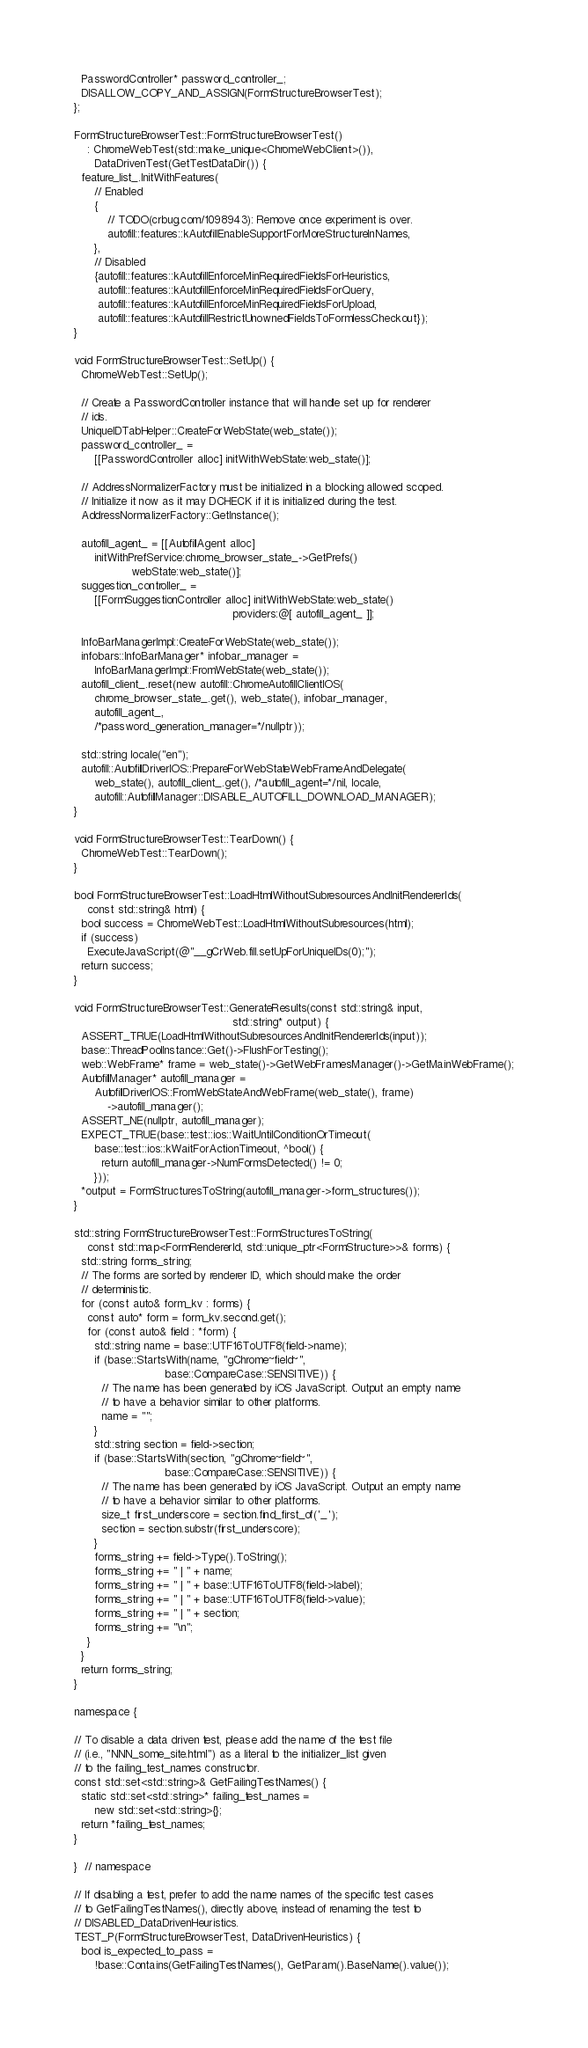Convert code to text. <code><loc_0><loc_0><loc_500><loc_500><_ObjectiveC_>  PasswordController* password_controller_;
  DISALLOW_COPY_AND_ASSIGN(FormStructureBrowserTest);
};

FormStructureBrowserTest::FormStructureBrowserTest()
    : ChromeWebTest(std::make_unique<ChromeWebClient>()),
      DataDrivenTest(GetTestDataDir()) {
  feature_list_.InitWithFeatures(
      // Enabled
      {
          // TODO(crbug.com/1098943): Remove once experiment is over.
          autofill::features::kAutofillEnableSupportForMoreStructureInNames,
      },
      // Disabled
      {autofill::features::kAutofillEnforceMinRequiredFieldsForHeuristics,
       autofill::features::kAutofillEnforceMinRequiredFieldsForQuery,
       autofill::features::kAutofillEnforceMinRequiredFieldsForUpload,
       autofill::features::kAutofillRestrictUnownedFieldsToFormlessCheckout});
}

void FormStructureBrowserTest::SetUp() {
  ChromeWebTest::SetUp();

  // Create a PasswordController instance that will handle set up for renderer
  // ids.
  UniqueIDTabHelper::CreateForWebState(web_state());
  password_controller_ =
      [[PasswordController alloc] initWithWebState:web_state()];

  // AddressNormalizerFactory must be initialized in a blocking allowed scoped.
  // Initialize it now as it may DCHECK if it is initialized during the test.
  AddressNormalizerFactory::GetInstance();

  autofill_agent_ = [[AutofillAgent alloc]
      initWithPrefService:chrome_browser_state_->GetPrefs()
                 webState:web_state()];
  suggestion_controller_ =
      [[FormSuggestionController alloc] initWithWebState:web_state()
                                               providers:@[ autofill_agent_ ]];

  InfoBarManagerImpl::CreateForWebState(web_state());
  infobars::InfoBarManager* infobar_manager =
      InfoBarManagerImpl::FromWebState(web_state());
  autofill_client_.reset(new autofill::ChromeAutofillClientIOS(
      chrome_browser_state_.get(), web_state(), infobar_manager,
      autofill_agent_,
      /*password_generation_manager=*/nullptr));

  std::string locale("en");
  autofill::AutofillDriverIOS::PrepareForWebStateWebFrameAndDelegate(
      web_state(), autofill_client_.get(), /*autofill_agent=*/nil, locale,
      autofill::AutofillManager::DISABLE_AUTOFILL_DOWNLOAD_MANAGER);
}

void FormStructureBrowserTest::TearDown() {
  ChromeWebTest::TearDown();
}

bool FormStructureBrowserTest::LoadHtmlWithoutSubresourcesAndInitRendererIds(
    const std::string& html) {
  bool success = ChromeWebTest::LoadHtmlWithoutSubresources(html);
  if (success)
    ExecuteJavaScript(@"__gCrWeb.fill.setUpForUniqueIDs(0);");
  return success;
}

void FormStructureBrowserTest::GenerateResults(const std::string& input,
                                               std::string* output) {
  ASSERT_TRUE(LoadHtmlWithoutSubresourcesAndInitRendererIds(input));
  base::ThreadPoolInstance::Get()->FlushForTesting();
  web::WebFrame* frame = web_state()->GetWebFramesManager()->GetMainWebFrame();
  AutofillManager* autofill_manager =
      AutofillDriverIOS::FromWebStateAndWebFrame(web_state(), frame)
          ->autofill_manager();
  ASSERT_NE(nullptr, autofill_manager);
  EXPECT_TRUE(base::test::ios::WaitUntilConditionOrTimeout(
      base::test::ios::kWaitForActionTimeout, ^bool() {
        return autofill_manager->NumFormsDetected() != 0;
      }));
  *output = FormStructuresToString(autofill_manager->form_structures());
}

std::string FormStructureBrowserTest::FormStructuresToString(
    const std::map<FormRendererId, std::unique_ptr<FormStructure>>& forms) {
  std::string forms_string;
  // The forms are sorted by renderer ID, which should make the order
  // deterministic.
  for (const auto& form_kv : forms) {
    const auto* form = form_kv.second.get();
    for (const auto& field : *form) {
      std::string name = base::UTF16ToUTF8(field->name);
      if (base::StartsWith(name, "gChrome~field~",
                           base::CompareCase::SENSITIVE)) {
        // The name has been generated by iOS JavaScript. Output an empty name
        // to have a behavior similar to other platforms.
        name = "";
      }
      std::string section = field->section;
      if (base::StartsWith(section, "gChrome~field~",
                           base::CompareCase::SENSITIVE)) {
        // The name has been generated by iOS JavaScript. Output an empty name
        // to have a behavior similar to other platforms.
        size_t first_underscore = section.find_first_of('_');
        section = section.substr(first_underscore);
      }
      forms_string += field->Type().ToString();
      forms_string += " | " + name;
      forms_string += " | " + base::UTF16ToUTF8(field->label);
      forms_string += " | " + base::UTF16ToUTF8(field->value);
      forms_string += " | " + section;
      forms_string += "\n";
    }
  }
  return forms_string;
}

namespace {

// To disable a data driven test, please add the name of the test file
// (i.e., "NNN_some_site.html") as a literal to the initializer_list given
// to the failing_test_names constructor.
const std::set<std::string>& GetFailingTestNames() {
  static std::set<std::string>* failing_test_names =
      new std::set<std::string>{};
  return *failing_test_names;
}

}  // namespace

// If disabling a test, prefer to add the name names of the specific test cases
// to GetFailingTestNames(), directly above, instead of renaming the test to
// DISABLED_DataDrivenHeuristics.
TEST_P(FormStructureBrowserTest, DataDrivenHeuristics) {
  bool is_expected_to_pass =
      !base::Contains(GetFailingTestNames(), GetParam().BaseName().value());</code> 